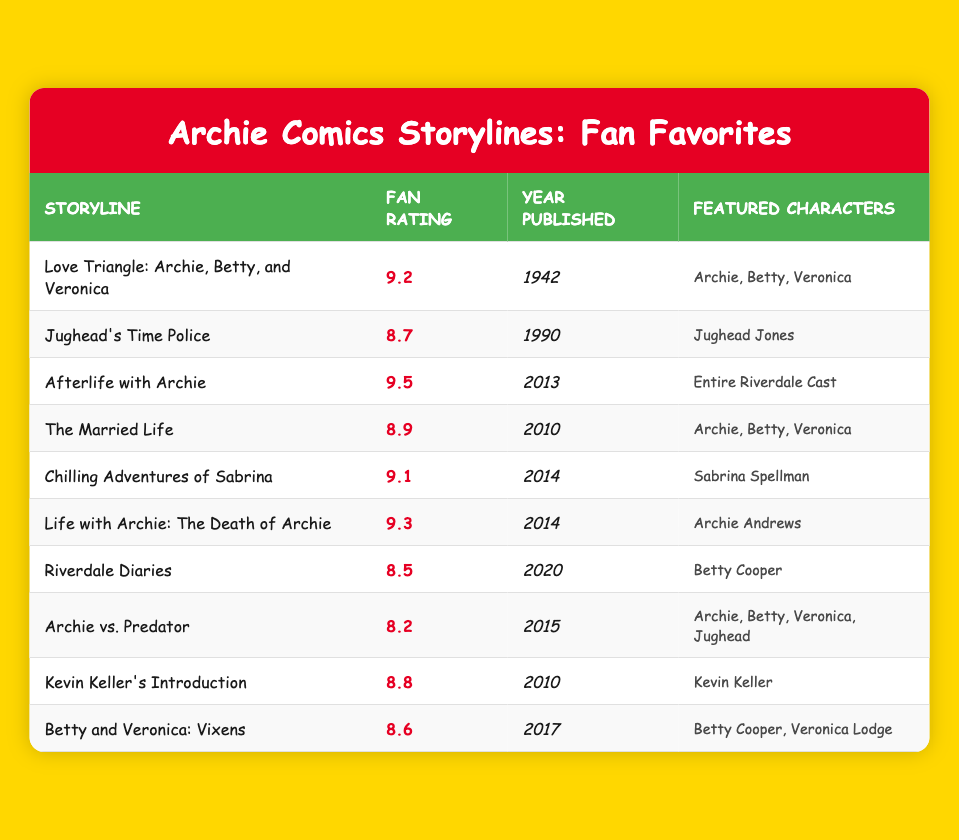What is the fan rating for "Afterlife with Archie"? The table shows that the fan rating for the storyline "Afterlife with Archie" is listed as 9.5.
Answer: 9.5 Who are the featured characters in "Chilling Adventures of Sabrina"? Referring to the table, the featured characters in "Chilling Adventures of Sabrina" are shown as "Sabrina Spellman."
Answer: Sabrina Spellman Which storyline has the highest fan rating? By examining the fan ratings in the table, "Afterlife with Archie" has the highest rating at 9.5.
Answer: Afterlife with Archie What is the average fan rating of storylines published after the year 2010? The relevant storylines with their ratings are "The Married Life" (8.9), "Chilling Adventures of Sabrina" (9.1), "Life with Archie: The Death of Archie" (9.3), "Riverdale Diaries" (8.5), "Betty and Veronica: Vixens" (8.6), and "Kevin Keller's Introduction" (8.8). Summing these ratings gives 8.9 + 9.1 + 9.3 + 8.5 + 8.6 + 8.8 = 53.2. There are 6 storylines, so the average rating is 53.2 / 6 = 8.87.
Answer: 8.87 Does the storyline "Jughead's Time Police" have a fan rating lower than 9? The table indicates that "Jughead's Time Police" has a fan rating of 8.7, which is indeed lower than 9.
Answer: Yes 